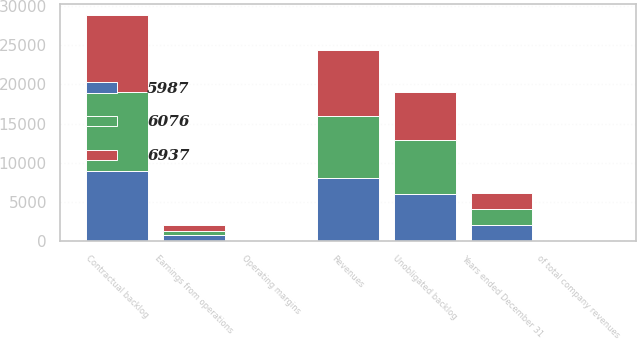Convert chart. <chart><loc_0><loc_0><loc_500><loc_500><stacked_bar_chart><ecel><fcel>Years ended December 31<fcel>Revenues<fcel>of total company revenues<fcel>Earnings from operations<fcel>Operating margins<fcel>Contractual backlog<fcel>Unobligated backlog<nl><fcel>5987<fcel>2014<fcel>8003<fcel>9<fcel>698<fcel>8.7<fcel>8935<fcel>5987<nl><fcel>6937<fcel>2013<fcel>8512<fcel>10<fcel>719<fcel>8.4<fcel>9832<fcel>6076<nl><fcel>6076<fcel>2012<fcel>7911<fcel>10<fcel>562<fcel>7.1<fcel>10078<fcel>6937<nl></chart> 